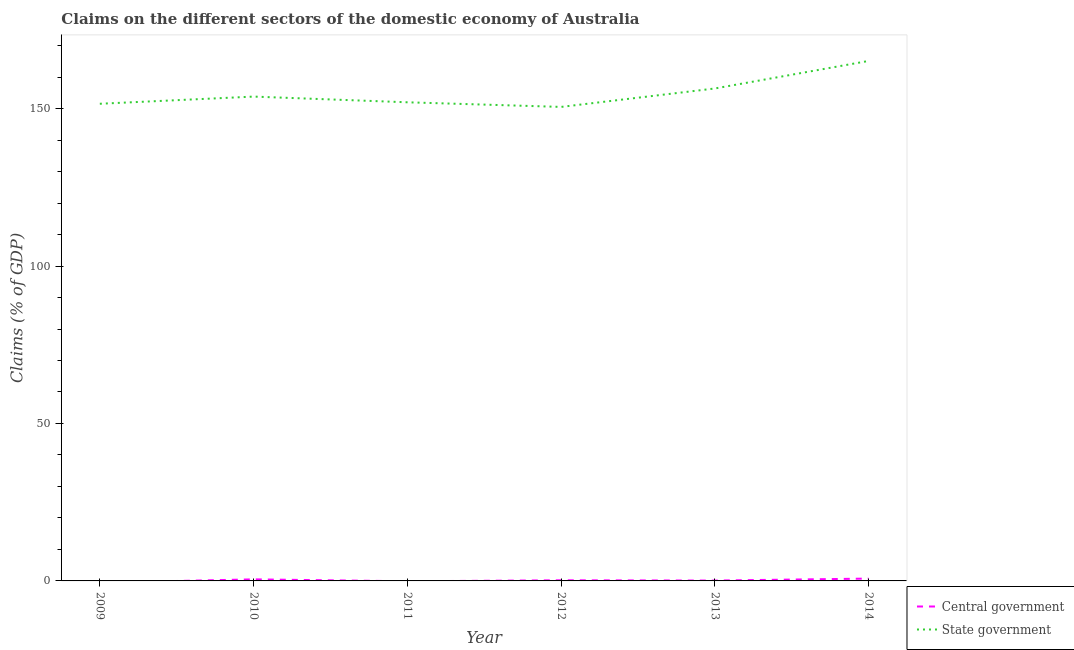Is the number of lines equal to the number of legend labels?
Offer a very short reply. No. What is the claims on state government in 2013?
Your answer should be very brief. 156.39. Across all years, what is the maximum claims on state government?
Your response must be concise. 165.13. Across all years, what is the minimum claims on state government?
Your answer should be compact. 150.53. What is the total claims on state government in the graph?
Provide a short and direct response. 929.41. What is the difference between the claims on state government in 2011 and that in 2012?
Your response must be concise. 1.47. What is the difference between the claims on central government in 2012 and the claims on state government in 2013?
Keep it short and to the point. -156.19. What is the average claims on state government per year?
Keep it short and to the point. 154.9. In the year 2013, what is the difference between the claims on state government and claims on central government?
Offer a terse response. 156.27. In how many years, is the claims on state government greater than 140 %?
Give a very brief answer. 6. What is the ratio of the claims on state government in 2009 to that in 2012?
Ensure brevity in your answer.  1.01. What is the difference between the highest and the second highest claims on central government?
Keep it short and to the point. 0.25. What is the difference between the highest and the lowest claims on central government?
Provide a succinct answer. 0.74. Is the claims on state government strictly greater than the claims on central government over the years?
Keep it short and to the point. Yes. Is the claims on central government strictly less than the claims on state government over the years?
Provide a succinct answer. Yes. How many years are there in the graph?
Your answer should be very brief. 6. Are the values on the major ticks of Y-axis written in scientific E-notation?
Make the answer very short. No. Does the graph contain grids?
Give a very brief answer. No. What is the title of the graph?
Ensure brevity in your answer.  Claims on the different sectors of the domestic economy of Australia. Does "Primary education" appear as one of the legend labels in the graph?
Give a very brief answer. No. What is the label or title of the Y-axis?
Your answer should be very brief. Claims (% of GDP). What is the Claims (% of GDP) in Central government in 2009?
Provide a short and direct response. 0. What is the Claims (% of GDP) of State government in 2009?
Make the answer very short. 151.54. What is the Claims (% of GDP) of Central government in 2010?
Make the answer very short. 0.5. What is the Claims (% of GDP) in State government in 2010?
Give a very brief answer. 153.82. What is the Claims (% of GDP) of Central government in 2011?
Give a very brief answer. 0. What is the Claims (% of GDP) of State government in 2011?
Ensure brevity in your answer.  152. What is the Claims (% of GDP) of Central government in 2012?
Offer a very short reply. 0.2. What is the Claims (% of GDP) of State government in 2012?
Give a very brief answer. 150.53. What is the Claims (% of GDP) of Central government in 2013?
Provide a succinct answer. 0.11. What is the Claims (% of GDP) in State government in 2013?
Your answer should be compact. 156.39. What is the Claims (% of GDP) in Central government in 2014?
Provide a short and direct response. 0.74. What is the Claims (% of GDP) of State government in 2014?
Provide a short and direct response. 165.13. Across all years, what is the maximum Claims (% of GDP) of Central government?
Your answer should be very brief. 0.74. Across all years, what is the maximum Claims (% of GDP) of State government?
Your response must be concise. 165.13. Across all years, what is the minimum Claims (% of GDP) in Central government?
Provide a succinct answer. 0. Across all years, what is the minimum Claims (% of GDP) of State government?
Your response must be concise. 150.53. What is the total Claims (% of GDP) of Central government in the graph?
Make the answer very short. 1.56. What is the total Claims (% of GDP) in State government in the graph?
Provide a succinct answer. 929.41. What is the difference between the Claims (% of GDP) of State government in 2009 and that in 2010?
Keep it short and to the point. -2.28. What is the difference between the Claims (% of GDP) of State government in 2009 and that in 2011?
Your response must be concise. -0.47. What is the difference between the Claims (% of GDP) of State government in 2009 and that in 2013?
Your answer should be very brief. -4.85. What is the difference between the Claims (% of GDP) of State government in 2009 and that in 2014?
Offer a terse response. -13.59. What is the difference between the Claims (% of GDP) of State government in 2010 and that in 2011?
Give a very brief answer. 1.81. What is the difference between the Claims (% of GDP) of Central government in 2010 and that in 2012?
Your response must be concise. 0.29. What is the difference between the Claims (% of GDP) of State government in 2010 and that in 2012?
Ensure brevity in your answer.  3.28. What is the difference between the Claims (% of GDP) in Central government in 2010 and that in 2013?
Offer a terse response. 0.38. What is the difference between the Claims (% of GDP) of State government in 2010 and that in 2013?
Provide a short and direct response. -2.57. What is the difference between the Claims (% of GDP) of Central government in 2010 and that in 2014?
Make the answer very short. -0.25. What is the difference between the Claims (% of GDP) in State government in 2010 and that in 2014?
Give a very brief answer. -11.31. What is the difference between the Claims (% of GDP) in State government in 2011 and that in 2012?
Provide a short and direct response. 1.47. What is the difference between the Claims (% of GDP) of State government in 2011 and that in 2013?
Make the answer very short. -4.38. What is the difference between the Claims (% of GDP) in State government in 2011 and that in 2014?
Ensure brevity in your answer.  -13.13. What is the difference between the Claims (% of GDP) of Central government in 2012 and that in 2013?
Give a very brief answer. 0.09. What is the difference between the Claims (% of GDP) in State government in 2012 and that in 2013?
Provide a succinct answer. -5.85. What is the difference between the Claims (% of GDP) of Central government in 2012 and that in 2014?
Offer a terse response. -0.54. What is the difference between the Claims (% of GDP) in State government in 2012 and that in 2014?
Make the answer very short. -14.6. What is the difference between the Claims (% of GDP) in Central government in 2013 and that in 2014?
Provide a short and direct response. -0.63. What is the difference between the Claims (% of GDP) of State government in 2013 and that in 2014?
Provide a succinct answer. -8.74. What is the difference between the Claims (% of GDP) of Central government in 2010 and the Claims (% of GDP) of State government in 2011?
Make the answer very short. -151.51. What is the difference between the Claims (% of GDP) of Central government in 2010 and the Claims (% of GDP) of State government in 2012?
Give a very brief answer. -150.04. What is the difference between the Claims (% of GDP) of Central government in 2010 and the Claims (% of GDP) of State government in 2013?
Give a very brief answer. -155.89. What is the difference between the Claims (% of GDP) of Central government in 2010 and the Claims (% of GDP) of State government in 2014?
Provide a succinct answer. -164.63. What is the difference between the Claims (% of GDP) in Central government in 2012 and the Claims (% of GDP) in State government in 2013?
Keep it short and to the point. -156.19. What is the difference between the Claims (% of GDP) in Central government in 2012 and the Claims (% of GDP) in State government in 2014?
Provide a succinct answer. -164.93. What is the difference between the Claims (% of GDP) of Central government in 2013 and the Claims (% of GDP) of State government in 2014?
Offer a terse response. -165.02. What is the average Claims (% of GDP) in Central government per year?
Offer a very short reply. 0.26. What is the average Claims (% of GDP) in State government per year?
Ensure brevity in your answer.  154.9. In the year 2010, what is the difference between the Claims (% of GDP) of Central government and Claims (% of GDP) of State government?
Ensure brevity in your answer.  -153.32. In the year 2012, what is the difference between the Claims (% of GDP) in Central government and Claims (% of GDP) in State government?
Provide a succinct answer. -150.33. In the year 2013, what is the difference between the Claims (% of GDP) in Central government and Claims (% of GDP) in State government?
Give a very brief answer. -156.27. In the year 2014, what is the difference between the Claims (% of GDP) in Central government and Claims (% of GDP) in State government?
Offer a terse response. -164.39. What is the ratio of the Claims (% of GDP) of State government in 2009 to that in 2010?
Ensure brevity in your answer.  0.99. What is the ratio of the Claims (% of GDP) of State government in 2009 to that in 2013?
Keep it short and to the point. 0.97. What is the ratio of the Claims (% of GDP) in State government in 2009 to that in 2014?
Ensure brevity in your answer.  0.92. What is the ratio of the Claims (% of GDP) of State government in 2010 to that in 2011?
Provide a succinct answer. 1.01. What is the ratio of the Claims (% of GDP) of Central government in 2010 to that in 2012?
Your response must be concise. 2.45. What is the ratio of the Claims (% of GDP) of State government in 2010 to that in 2012?
Ensure brevity in your answer.  1.02. What is the ratio of the Claims (% of GDP) in Central government in 2010 to that in 2013?
Your answer should be very brief. 4.37. What is the ratio of the Claims (% of GDP) of State government in 2010 to that in 2013?
Your answer should be very brief. 0.98. What is the ratio of the Claims (% of GDP) of Central government in 2010 to that in 2014?
Offer a terse response. 0.67. What is the ratio of the Claims (% of GDP) in State government in 2010 to that in 2014?
Your answer should be very brief. 0.93. What is the ratio of the Claims (% of GDP) of State government in 2011 to that in 2012?
Your answer should be very brief. 1.01. What is the ratio of the Claims (% of GDP) in State government in 2011 to that in 2013?
Ensure brevity in your answer.  0.97. What is the ratio of the Claims (% of GDP) of State government in 2011 to that in 2014?
Give a very brief answer. 0.92. What is the ratio of the Claims (% of GDP) of Central government in 2012 to that in 2013?
Your answer should be very brief. 1.78. What is the ratio of the Claims (% of GDP) of State government in 2012 to that in 2013?
Your response must be concise. 0.96. What is the ratio of the Claims (% of GDP) of Central government in 2012 to that in 2014?
Provide a short and direct response. 0.27. What is the ratio of the Claims (% of GDP) in State government in 2012 to that in 2014?
Make the answer very short. 0.91. What is the ratio of the Claims (% of GDP) in Central government in 2013 to that in 2014?
Ensure brevity in your answer.  0.15. What is the ratio of the Claims (% of GDP) of State government in 2013 to that in 2014?
Provide a succinct answer. 0.95. What is the difference between the highest and the second highest Claims (% of GDP) of Central government?
Give a very brief answer. 0.25. What is the difference between the highest and the second highest Claims (% of GDP) of State government?
Provide a short and direct response. 8.74. What is the difference between the highest and the lowest Claims (% of GDP) in Central government?
Give a very brief answer. 0.74. What is the difference between the highest and the lowest Claims (% of GDP) of State government?
Your response must be concise. 14.6. 